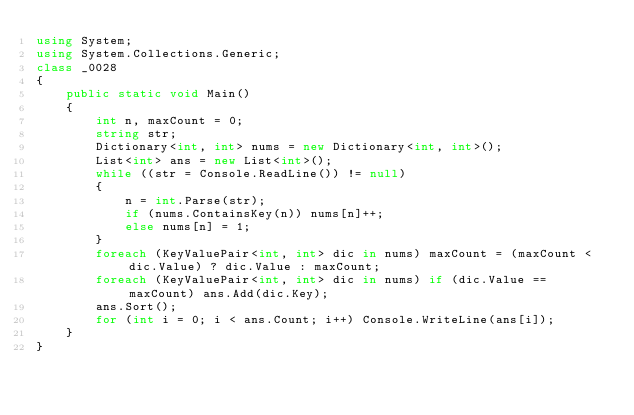<code> <loc_0><loc_0><loc_500><loc_500><_C#_>using System;
using System.Collections.Generic;
class _0028
{
    public static void Main()
    {
        int n, maxCount = 0;
        string str;
        Dictionary<int, int> nums = new Dictionary<int, int>();
        List<int> ans = new List<int>();
        while ((str = Console.ReadLine()) != null)
        {
            n = int.Parse(str);
            if (nums.ContainsKey(n)) nums[n]++;
            else nums[n] = 1;
        }
        foreach (KeyValuePair<int, int> dic in nums) maxCount = (maxCount < dic.Value) ? dic.Value : maxCount;
        foreach (KeyValuePair<int, int> dic in nums) if (dic.Value == maxCount) ans.Add(dic.Key);
        ans.Sort();
        for (int i = 0; i < ans.Count; i++) Console.WriteLine(ans[i]);
    }
}</code> 